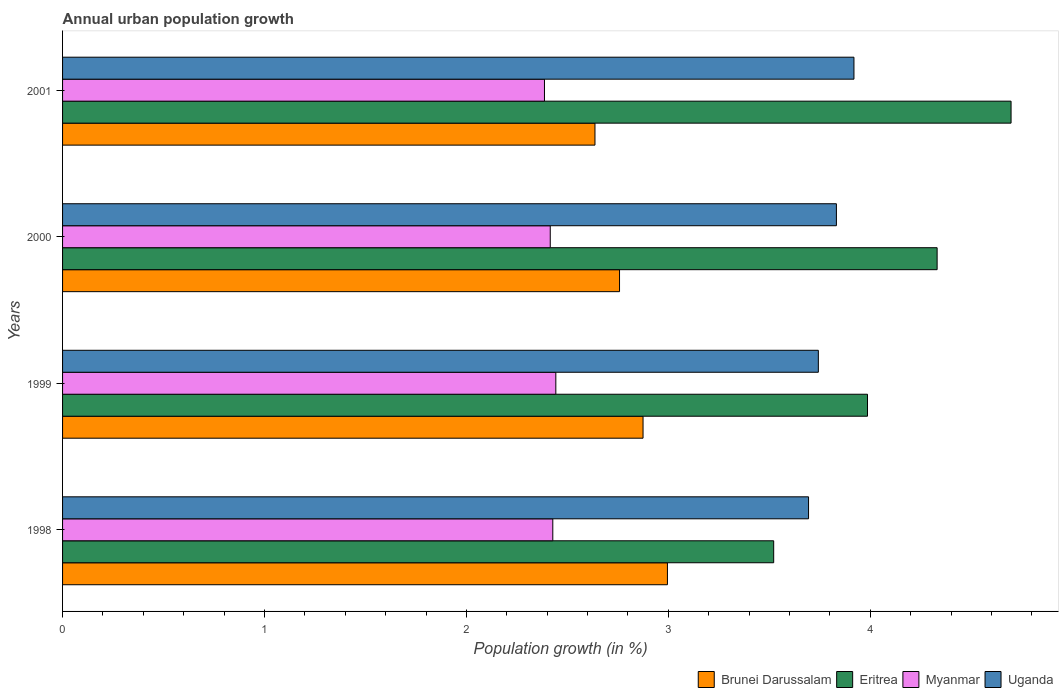How many different coloured bars are there?
Your answer should be compact. 4. Are the number of bars on each tick of the Y-axis equal?
Provide a short and direct response. Yes. How many bars are there on the 3rd tick from the bottom?
Offer a terse response. 4. In how many cases, is the number of bars for a given year not equal to the number of legend labels?
Provide a short and direct response. 0. What is the percentage of urban population growth in Uganda in 2000?
Offer a very short reply. 3.83. Across all years, what is the maximum percentage of urban population growth in Myanmar?
Ensure brevity in your answer.  2.44. Across all years, what is the minimum percentage of urban population growth in Myanmar?
Offer a terse response. 2.39. What is the total percentage of urban population growth in Eritrea in the graph?
Offer a very short reply. 16.54. What is the difference between the percentage of urban population growth in Uganda in 1998 and that in 2000?
Offer a very short reply. -0.14. What is the difference between the percentage of urban population growth in Brunei Darussalam in 1998 and the percentage of urban population growth in Myanmar in 1999?
Offer a very short reply. 0.55. What is the average percentage of urban population growth in Eritrea per year?
Your answer should be compact. 4.13. In the year 1999, what is the difference between the percentage of urban population growth in Uganda and percentage of urban population growth in Eritrea?
Your answer should be compact. -0.24. In how many years, is the percentage of urban population growth in Myanmar greater than 0.8 %?
Make the answer very short. 4. What is the ratio of the percentage of urban population growth in Myanmar in 1998 to that in 2001?
Offer a terse response. 1.02. Is the difference between the percentage of urban population growth in Uganda in 1998 and 2000 greater than the difference between the percentage of urban population growth in Eritrea in 1998 and 2000?
Offer a very short reply. Yes. What is the difference between the highest and the second highest percentage of urban population growth in Myanmar?
Provide a succinct answer. 0.01. What is the difference between the highest and the lowest percentage of urban population growth in Myanmar?
Offer a terse response. 0.06. In how many years, is the percentage of urban population growth in Myanmar greater than the average percentage of urban population growth in Myanmar taken over all years?
Offer a terse response. 2. Is the sum of the percentage of urban population growth in Myanmar in 1999 and 2001 greater than the maximum percentage of urban population growth in Brunei Darussalam across all years?
Offer a terse response. Yes. Is it the case that in every year, the sum of the percentage of urban population growth in Eritrea and percentage of urban population growth in Myanmar is greater than the sum of percentage of urban population growth in Uganda and percentage of urban population growth in Brunei Darussalam?
Your answer should be compact. No. What does the 1st bar from the top in 2000 represents?
Ensure brevity in your answer.  Uganda. What does the 4th bar from the bottom in 1998 represents?
Make the answer very short. Uganda. Is it the case that in every year, the sum of the percentage of urban population growth in Uganda and percentage of urban population growth in Eritrea is greater than the percentage of urban population growth in Brunei Darussalam?
Offer a very short reply. Yes. How many bars are there?
Offer a very short reply. 16. Are all the bars in the graph horizontal?
Provide a short and direct response. Yes. How many years are there in the graph?
Offer a terse response. 4. Are the values on the major ticks of X-axis written in scientific E-notation?
Your answer should be very brief. No. Does the graph contain grids?
Your response must be concise. No. Where does the legend appear in the graph?
Provide a succinct answer. Bottom right. How many legend labels are there?
Your answer should be compact. 4. How are the legend labels stacked?
Provide a short and direct response. Horizontal. What is the title of the graph?
Offer a terse response. Annual urban population growth. What is the label or title of the X-axis?
Give a very brief answer. Population growth (in %). What is the Population growth (in %) in Brunei Darussalam in 1998?
Ensure brevity in your answer.  3. What is the Population growth (in %) of Eritrea in 1998?
Your response must be concise. 3.52. What is the Population growth (in %) in Myanmar in 1998?
Make the answer very short. 2.43. What is the Population growth (in %) of Uganda in 1998?
Make the answer very short. 3.69. What is the Population growth (in %) in Brunei Darussalam in 1999?
Offer a very short reply. 2.87. What is the Population growth (in %) of Eritrea in 1999?
Your answer should be compact. 3.99. What is the Population growth (in %) in Myanmar in 1999?
Give a very brief answer. 2.44. What is the Population growth (in %) of Uganda in 1999?
Offer a terse response. 3.74. What is the Population growth (in %) of Brunei Darussalam in 2000?
Your answer should be compact. 2.76. What is the Population growth (in %) in Eritrea in 2000?
Provide a succinct answer. 4.33. What is the Population growth (in %) of Myanmar in 2000?
Provide a short and direct response. 2.42. What is the Population growth (in %) of Uganda in 2000?
Make the answer very short. 3.83. What is the Population growth (in %) of Brunei Darussalam in 2001?
Your answer should be compact. 2.64. What is the Population growth (in %) in Eritrea in 2001?
Your answer should be very brief. 4.7. What is the Population growth (in %) in Myanmar in 2001?
Your answer should be compact. 2.39. What is the Population growth (in %) in Uganda in 2001?
Offer a terse response. 3.92. Across all years, what is the maximum Population growth (in %) of Brunei Darussalam?
Provide a succinct answer. 3. Across all years, what is the maximum Population growth (in %) of Eritrea?
Your response must be concise. 4.7. Across all years, what is the maximum Population growth (in %) in Myanmar?
Ensure brevity in your answer.  2.44. Across all years, what is the maximum Population growth (in %) in Uganda?
Your answer should be very brief. 3.92. Across all years, what is the minimum Population growth (in %) in Brunei Darussalam?
Provide a succinct answer. 2.64. Across all years, what is the minimum Population growth (in %) of Eritrea?
Your response must be concise. 3.52. Across all years, what is the minimum Population growth (in %) in Myanmar?
Give a very brief answer. 2.39. Across all years, what is the minimum Population growth (in %) of Uganda?
Offer a very short reply. 3.69. What is the total Population growth (in %) in Brunei Darussalam in the graph?
Offer a very short reply. 11.27. What is the total Population growth (in %) in Eritrea in the graph?
Your response must be concise. 16.54. What is the total Population growth (in %) in Myanmar in the graph?
Provide a succinct answer. 9.67. What is the total Population growth (in %) in Uganda in the graph?
Your answer should be compact. 15.19. What is the difference between the Population growth (in %) in Brunei Darussalam in 1998 and that in 1999?
Provide a short and direct response. 0.12. What is the difference between the Population growth (in %) in Eritrea in 1998 and that in 1999?
Your answer should be compact. -0.46. What is the difference between the Population growth (in %) in Myanmar in 1998 and that in 1999?
Provide a succinct answer. -0.01. What is the difference between the Population growth (in %) of Uganda in 1998 and that in 1999?
Keep it short and to the point. -0.05. What is the difference between the Population growth (in %) of Brunei Darussalam in 1998 and that in 2000?
Keep it short and to the point. 0.24. What is the difference between the Population growth (in %) in Eritrea in 1998 and that in 2000?
Make the answer very short. -0.81. What is the difference between the Population growth (in %) of Myanmar in 1998 and that in 2000?
Make the answer very short. 0.01. What is the difference between the Population growth (in %) of Uganda in 1998 and that in 2000?
Your answer should be very brief. -0.14. What is the difference between the Population growth (in %) in Brunei Darussalam in 1998 and that in 2001?
Offer a very short reply. 0.36. What is the difference between the Population growth (in %) in Eritrea in 1998 and that in 2001?
Give a very brief answer. -1.18. What is the difference between the Population growth (in %) in Myanmar in 1998 and that in 2001?
Provide a short and direct response. 0.04. What is the difference between the Population growth (in %) in Uganda in 1998 and that in 2001?
Give a very brief answer. -0.22. What is the difference between the Population growth (in %) of Brunei Darussalam in 1999 and that in 2000?
Make the answer very short. 0.12. What is the difference between the Population growth (in %) in Eritrea in 1999 and that in 2000?
Offer a terse response. -0.34. What is the difference between the Population growth (in %) in Myanmar in 1999 and that in 2000?
Your response must be concise. 0.03. What is the difference between the Population growth (in %) of Uganda in 1999 and that in 2000?
Provide a succinct answer. -0.09. What is the difference between the Population growth (in %) of Brunei Darussalam in 1999 and that in 2001?
Offer a terse response. 0.24. What is the difference between the Population growth (in %) in Eritrea in 1999 and that in 2001?
Provide a short and direct response. -0.71. What is the difference between the Population growth (in %) in Myanmar in 1999 and that in 2001?
Provide a succinct answer. 0.06. What is the difference between the Population growth (in %) in Uganda in 1999 and that in 2001?
Your response must be concise. -0.18. What is the difference between the Population growth (in %) in Brunei Darussalam in 2000 and that in 2001?
Your answer should be compact. 0.12. What is the difference between the Population growth (in %) in Eritrea in 2000 and that in 2001?
Ensure brevity in your answer.  -0.37. What is the difference between the Population growth (in %) in Myanmar in 2000 and that in 2001?
Make the answer very short. 0.03. What is the difference between the Population growth (in %) in Uganda in 2000 and that in 2001?
Provide a short and direct response. -0.09. What is the difference between the Population growth (in %) in Brunei Darussalam in 1998 and the Population growth (in %) in Eritrea in 1999?
Your response must be concise. -0.99. What is the difference between the Population growth (in %) in Brunei Darussalam in 1998 and the Population growth (in %) in Myanmar in 1999?
Ensure brevity in your answer.  0.55. What is the difference between the Population growth (in %) in Brunei Darussalam in 1998 and the Population growth (in %) in Uganda in 1999?
Offer a very short reply. -0.75. What is the difference between the Population growth (in %) in Eritrea in 1998 and the Population growth (in %) in Myanmar in 1999?
Ensure brevity in your answer.  1.08. What is the difference between the Population growth (in %) of Eritrea in 1998 and the Population growth (in %) of Uganda in 1999?
Your answer should be very brief. -0.22. What is the difference between the Population growth (in %) of Myanmar in 1998 and the Population growth (in %) of Uganda in 1999?
Give a very brief answer. -1.32. What is the difference between the Population growth (in %) of Brunei Darussalam in 1998 and the Population growth (in %) of Eritrea in 2000?
Give a very brief answer. -1.34. What is the difference between the Population growth (in %) of Brunei Darussalam in 1998 and the Population growth (in %) of Myanmar in 2000?
Your answer should be very brief. 0.58. What is the difference between the Population growth (in %) of Brunei Darussalam in 1998 and the Population growth (in %) of Uganda in 2000?
Offer a terse response. -0.84. What is the difference between the Population growth (in %) of Eritrea in 1998 and the Population growth (in %) of Myanmar in 2000?
Provide a short and direct response. 1.11. What is the difference between the Population growth (in %) in Eritrea in 1998 and the Population growth (in %) in Uganda in 2000?
Give a very brief answer. -0.31. What is the difference between the Population growth (in %) in Myanmar in 1998 and the Population growth (in %) in Uganda in 2000?
Your answer should be compact. -1.4. What is the difference between the Population growth (in %) in Brunei Darussalam in 1998 and the Population growth (in %) in Eritrea in 2001?
Offer a terse response. -1.7. What is the difference between the Population growth (in %) in Brunei Darussalam in 1998 and the Population growth (in %) in Myanmar in 2001?
Provide a succinct answer. 0.61. What is the difference between the Population growth (in %) of Brunei Darussalam in 1998 and the Population growth (in %) of Uganda in 2001?
Provide a succinct answer. -0.92. What is the difference between the Population growth (in %) in Eritrea in 1998 and the Population growth (in %) in Myanmar in 2001?
Your answer should be very brief. 1.14. What is the difference between the Population growth (in %) of Eritrea in 1998 and the Population growth (in %) of Uganda in 2001?
Provide a short and direct response. -0.4. What is the difference between the Population growth (in %) in Myanmar in 1998 and the Population growth (in %) in Uganda in 2001?
Provide a succinct answer. -1.49. What is the difference between the Population growth (in %) in Brunei Darussalam in 1999 and the Population growth (in %) in Eritrea in 2000?
Make the answer very short. -1.46. What is the difference between the Population growth (in %) of Brunei Darussalam in 1999 and the Population growth (in %) of Myanmar in 2000?
Ensure brevity in your answer.  0.46. What is the difference between the Population growth (in %) in Brunei Darussalam in 1999 and the Population growth (in %) in Uganda in 2000?
Your answer should be very brief. -0.96. What is the difference between the Population growth (in %) in Eritrea in 1999 and the Population growth (in %) in Myanmar in 2000?
Give a very brief answer. 1.57. What is the difference between the Population growth (in %) of Eritrea in 1999 and the Population growth (in %) of Uganda in 2000?
Provide a succinct answer. 0.15. What is the difference between the Population growth (in %) of Myanmar in 1999 and the Population growth (in %) of Uganda in 2000?
Provide a short and direct response. -1.39. What is the difference between the Population growth (in %) of Brunei Darussalam in 1999 and the Population growth (in %) of Eritrea in 2001?
Offer a terse response. -1.82. What is the difference between the Population growth (in %) in Brunei Darussalam in 1999 and the Population growth (in %) in Myanmar in 2001?
Offer a very short reply. 0.49. What is the difference between the Population growth (in %) of Brunei Darussalam in 1999 and the Population growth (in %) of Uganda in 2001?
Offer a very short reply. -1.04. What is the difference between the Population growth (in %) in Eritrea in 1999 and the Population growth (in %) in Myanmar in 2001?
Give a very brief answer. 1.6. What is the difference between the Population growth (in %) in Eritrea in 1999 and the Population growth (in %) in Uganda in 2001?
Make the answer very short. 0.07. What is the difference between the Population growth (in %) in Myanmar in 1999 and the Population growth (in %) in Uganda in 2001?
Provide a short and direct response. -1.48. What is the difference between the Population growth (in %) of Brunei Darussalam in 2000 and the Population growth (in %) of Eritrea in 2001?
Your answer should be compact. -1.94. What is the difference between the Population growth (in %) in Brunei Darussalam in 2000 and the Population growth (in %) in Myanmar in 2001?
Make the answer very short. 0.37. What is the difference between the Population growth (in %) in Brunei Darussalam in 2000 and the Population growth (in %) in Uganda in 2001?
Your answer should be compact. -1.16. What is the difference between the Population growth (in %) in Eritrea in 2000 and the Population growth (in %) in Myanmar in 2001?
Your answer should be very brief. 1.94. What is the difference between the Population growth (in %) in Eritrea in 2000 and the Population growth (in %) in Uganda in 2001?
Provide a succinct answer. 0.41. What is the difference between the Population growth (in %) of Myanmar in 2000 and the Population growth (in %) of Uganda in 2001?
Your answer should be very brief. -1.5. What is the average Population growth (in %) in Brunei Darussalam per year?
Offer a very short reply. 2.82. What is the average Population growth (in %) of Eritrea per year?
Your answer should be compact. 4.13. What is the average Population growth (in %) of Myanmar per year?
Give a very brief answer. 2.42. What is the average Population growth (in %) of Uganda per year?
Give a very brief answer. 3.8. In the year 1998, what is the difference between the Population growth (in %) in Brunei Darussalam and Population growth (in %) in Eritrea?
Offer a very short reply. -0.53. In the year 1998, what is the difference between the Population growth (in %) of Brunei Darussalam and Population growth (in %) of Myanmar?
Ensure brevity in your answer.  0.57. In the year 1998, what is the difference between the Population growth (in %) in Brunei Darussalam and Population growth (in %) in Uganda?
Offer a very short reply. -0.7. In the year 1998, what is the difference between the Population growth (in %) in Eritrea and Population growth (in %) in Myanmar?
Ensure brevity in your answer.  1.09. In the year 1998, what is the difference between the Population growth (in %) in Eritrea and Population growth (in %) in Uganda?
Offer a very short reply. -0.17. In the year 1998, what is the difference between the Population growth (in %) in Myanmar and Population growth (in %) in Uganda?
Your response must be concise. -1.27. In the year 1999, what is the difference between the Population growth (in %) of Brunei Darussalam and Population growth (in %) of Eritrea?
Your answer should be compact. -1.11. In the year 1999, what is the difference between the Population growth (in %) of Brunei Darussalam and Population growth (in %) of Myanmar?
Provide a short and direct response. 0.43. In the year 1999, what is the difference between the Population growth (in %) of Brunei Darussalam and Population growth (in %) of Uganda?
Offer a very short reply. -0.87. In the year 1999, what is the difference between the Population growth (in %) of Eritrea and Population growth (in %) of Myanmar?
Give a very brief answer. 1.54. In the year 1999, what is the difference between the Population growth (in %) of Eritrea and Population growth (in %) of Uganda?
Offer a very short reply. 0.24. In the year 1999, what is the difference between the Population growth (in %) of Myanmar and Population growth (in %) of Uganda?
Make the answer very short. -1.3. In the year 2000, what is the difference between the Population growth (in %) in Brunei Darussalam and Population growth (in %) in Eritrea?
Offer a terse response. -1.57. In the year 2000, what is the difference between the Population growth (in %) in Brunei Darussalam and Population growth (in %) in Myanmar?
Your answer should be very brief. 0.34. In the year 2000, what is the difference between the Population growth (in %) of Brunei Darussalam and Population growth (in %) of Uganda?
Provide a succinct answer. -1.07. In the year 2000, what is the difference between the Population growth (in %) of Eritrea and Population growth (in %) of Myanmar?
Provide a succinct answer. 1.92. In the year 2000, what is the difference between the Population growth (in %) of Eritrea and Population growth (in %) of Uganda?
Your answer should be very brief. 0.5. In the year 2000, what is the difference between the Population growth (in %) in Myanmar and Population growth (in %) in Uganda?
Make the answer very short. -1.42. In the year 2001, what is the difference between the Population growth (in %) of Brunei Darussalam and Population growth (in %) of Eritrea?
Keep it short and to the point. -2.06. In the year 2001, what is the difference between the Population growth (in %) of Brunei Darussalam and Population growth (in %) of Myanmar?
Offer a terse response. 0.25. In the year 2001, what is the difference between the Population growth (in %) in Brunei Darussalam and Population growth (in %) in Uganda?
Ensure brevity in your answer.  -1.28. In the year 2001, what is the difference between the Population growth (in %) of Eritrea and Population growth (in %) of Myanmar?
Offer a terse response. 2.31. In the year 2001, what is the difference between the Population growth (in %) in Eritrea and Population growth (in %) in Uganda?
Your answer should be very brief. 0.78. In the year 2001, what is the difference between the Population growth (in %) of Myanmar and Population growth (in %) of Uganda?
Keep it short and to the point. -1.53. What is the ratio of the Population growth (in %) in Brunei Darussalam in 1998 to that in 1999?
Provide a succinct answer. 1.04. What is the ratio of the Population growth (in %) of Eritrea in 1998 to that in 1999?
Offer a terse response. 0.88. What is the ratio of the Population growth (in %) in Uganda in 1998 to that in 1999?
Your response must be concise. 0.99. What is the ratio of the Population growth (in %) of Brunei Darussalam in 1998 to that in 2000?
Offer a terse response. 1.09. What is the ratio of the Population growth (in %) in Eritrea in 1998 to that in 2000?
Your answer should be compact. 0.81. What is the ratio of the Population growth (in %) of Myanmar in 1998 to that in 2000?
Provide a short and direct response. 1.01. What is the ratio of the Population growth (in %) in Uganda in 1998 to that in 2000?
Provide a succinct answer. 0.96. What is the ratio of the Population growth (in %) in Brunei Darussalam in 1998 to that in 2001?
Make the answer very short. 1.14. What is the ratio of the Population growth (in %) of Eritrea in 1998 to that in 2001?
Your answer should be compact. 0.75. What is the ratio of the Population growth (in %) of Myanmar in 1998 to that in 2001?
Provide a short and direct response. 1.02. What is the ratio of the Population growth (in %) in Uganda in 1998 to that in 2001?
Your answer should be compact. 0.94. What is the ratio of the Population growth (in %) of Brunei Darussalam in 1999 to that in 2000?
Your response must be concise. 1.04. What is the ratio of the Population growth (in %) of Eritrea in 1999 to that in 2000?
Provide a short and direct response. 0.92. What is the ratio of the Population growth (in %) of Myanmar in 1999 to that in 2000?
Give a very brief answer. 1.01. What is the ratio of the Population growth (in %) in Uganda in 1999 to that in 2000?
Give a very brief answer. 0.98. What is the ratio of the Population growth (in %) in Brunei Darussalam in 1999 to that in 2001?
Offer a terse response. 1.09. What is the ratio of the Population growth (in %) in Eritrea in 1999 to that in 2001?
Make the answer very short. 0.85. What is the ratio of the Population growth (in %) of Myanmar in 1999 to that in 2001?
Your answer should be very brief. 1.02. What is the ratio of the Population growth (in %) in Uganda in 1999 to that in 2001?
Ensure brevity in your answer.  0.95. What is the ratio of the Population growth (in %) of Brunei Darussalam in 2000 to that in 2001?
Ensure brevity in your answer.  1.05. What is the ratio of the Population growth (in %) of Eritrea in 2000 to that in 2001?
Ensure brevity in your answer.  0.92. What is the ratio of the Population growth (in %) of Myanmar in 2000 to that in 2001?
Offer a terse response. 1.01. What is the ratio of the Population growth (in %) in Uganda in 2000 to that in 2001?
Ensure brevity in your answer.  0.98. What is the difference between the highest and the second highest Population growth (in %) in Brunei Darussalam?
Offer a very short reply. 0.12. What is the difference between the highest and the second highest Population growth (in %) of Eritrea?
Your answer should be very brief. 0.37. What is the difference between the highest and the second highest Population growth (in %) in Myanmar?
Ensure brevity in your answer.  0.01. What is the difference between the highest and the second highest Population growth (in %) in Uganda?
Offer a very short reply. 0.09. What is the difference between the highest and the lowest Population growth (in %) of Brunei Darussalam?
Offer a terse response. 0.36. What is the difference between the highest and the lowest Population growth (in %) of Eritrea?
Keep it short and to the point. 1.18. What is the difference between the highest and the lowest Population growth (in %) in Myanmar?
Give a very brief answer. 0.06. What is the difference between the highest and the lowest Population growth (in %) in Uganda?
Ensure brevity in your answer.  0.22. 